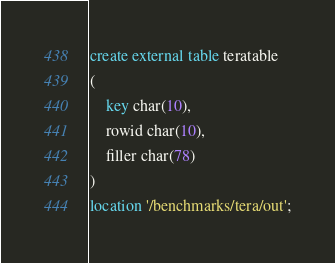Convert code to text. <code><loc_0><loc_0><loc_500><loc_500><_SQL_>
create external table teratable
(
    key char(10),
    rowid char(10),
    filler char(78)
)
location '/benchmarks/tera/out';
</code> 